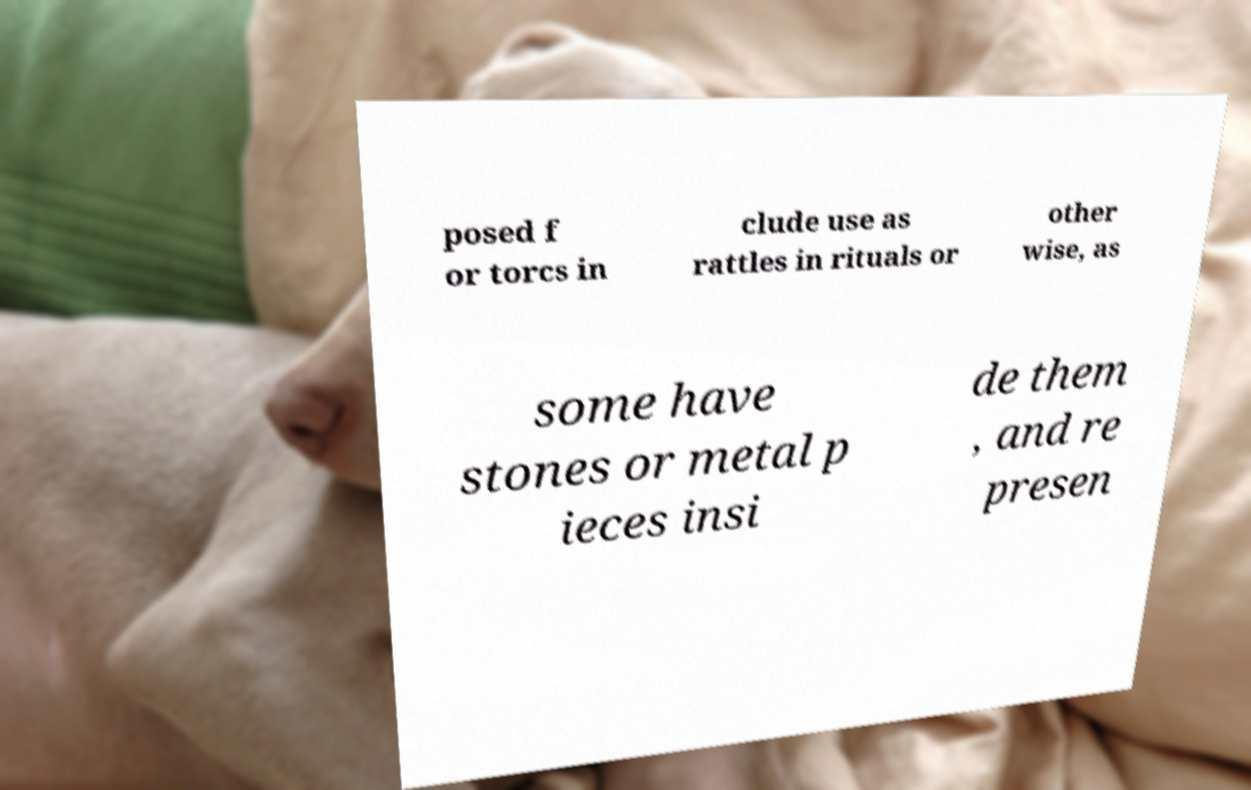Can you accurately transcribe the text from the provided image for me? posed f or torcs in clude use as rattles in rituals or other wise, as some have stones or metal p ieces insi de them , and re presen 